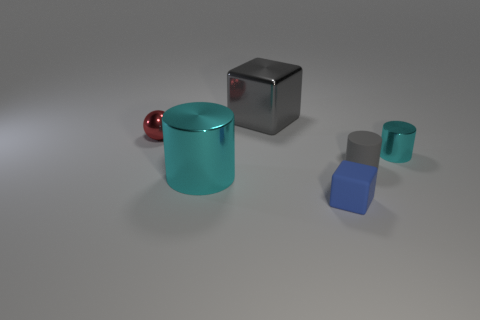Add 1 shiny balls. How many objects exist? 7 Subtract all blocks. How many objects are left? 4 Subtract all blue balls. Subtract all cylinders. How many objects are left? 3 Add 6 big gray objects. How many big gray objects are left? 7 Add 3 blue matte things. How many blue matte things exist? 4 Subtract 0 cyan blocks. How many objects are left? 6 